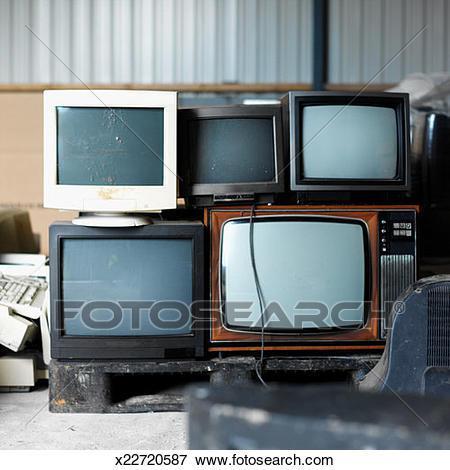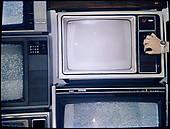The first image is the image on the left, the second image is the image on the right. Evaluate the accuracy of this statement regarding the images: "Each image shows vertical stacks containing at least eight TV sets, and no image includes any part of a human.". Is it true? Answer yes or no. No. The first image is the image on the left, the second image is the image on the right. Considering the images on both sides, is "There are less than five television sets  in at least one of the images." valid? Answer yes or no. Yes. 